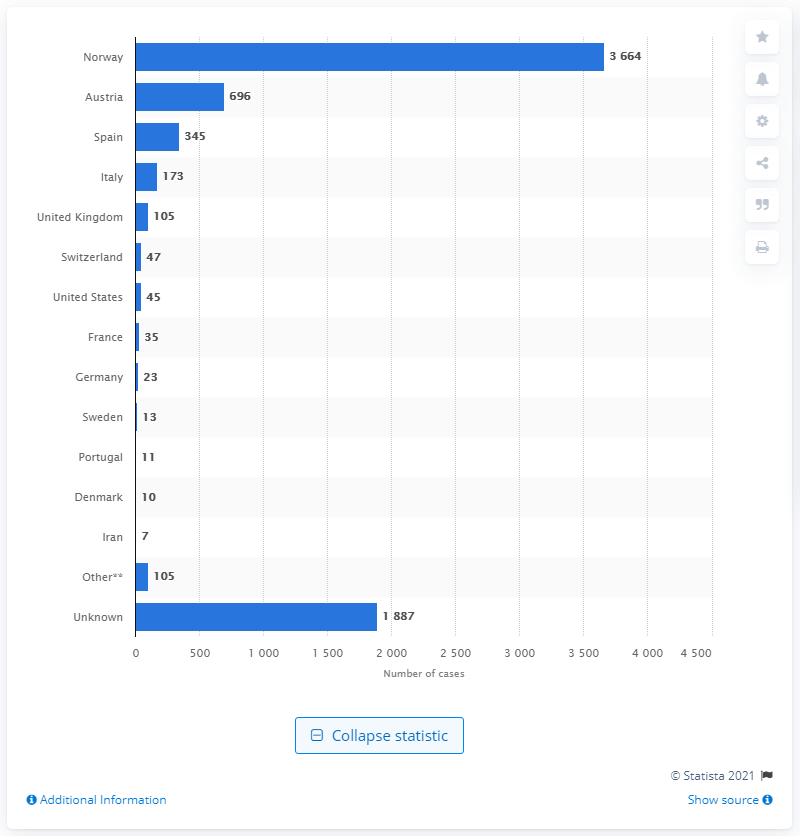Specify some key components in this picture. The second highest number of cases of coronavirus originated from Austria. 